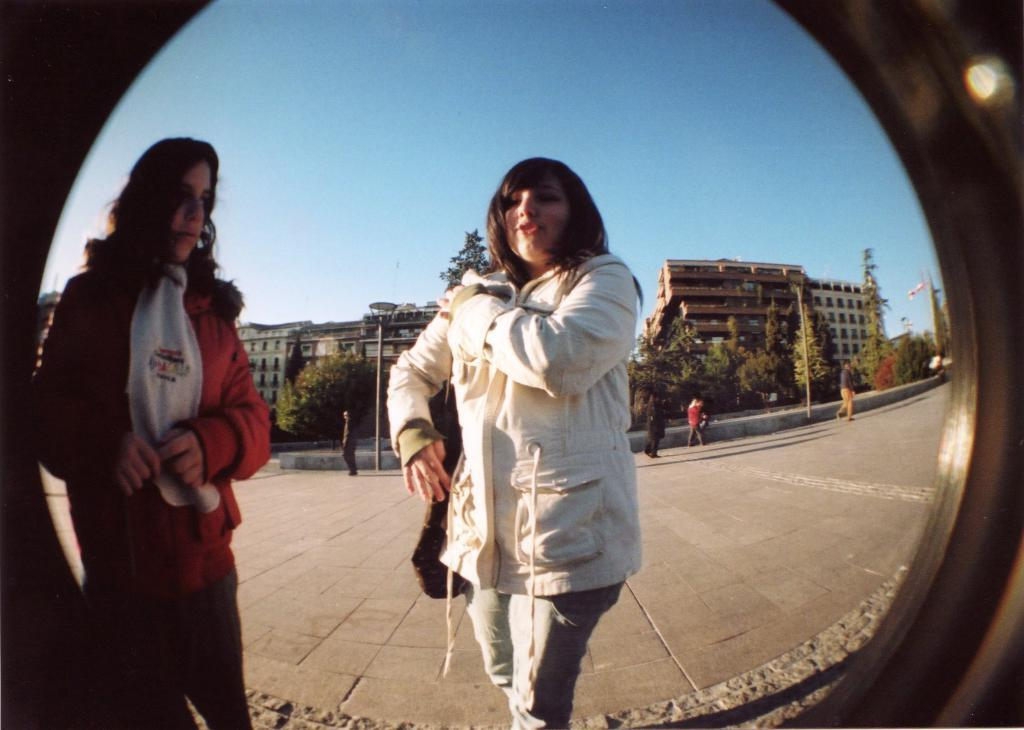What object is circular and made of glass in the image? There is a circular glass in the image. What can be seen through the circular glass? Two women are visible through the glass. Can you describe the people in the image besides the two women? There are other people in the image. What type of structures are present in the image? Poles and buildings are visible in the image. What type of natural elements can be seen in the image? Trees are visible in the image. What type of fork can be seen in the image? There is no fork present in the image. Can you describe the alley visible in the image? There is no alley present in the image. 